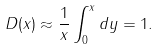<formula> <loc_0><loc_0><loc_500><loc_500>D ( x ) \approx \frac { 1 } { x } \int _ { 0 } ^ { x } d y = 1 .</formula> 